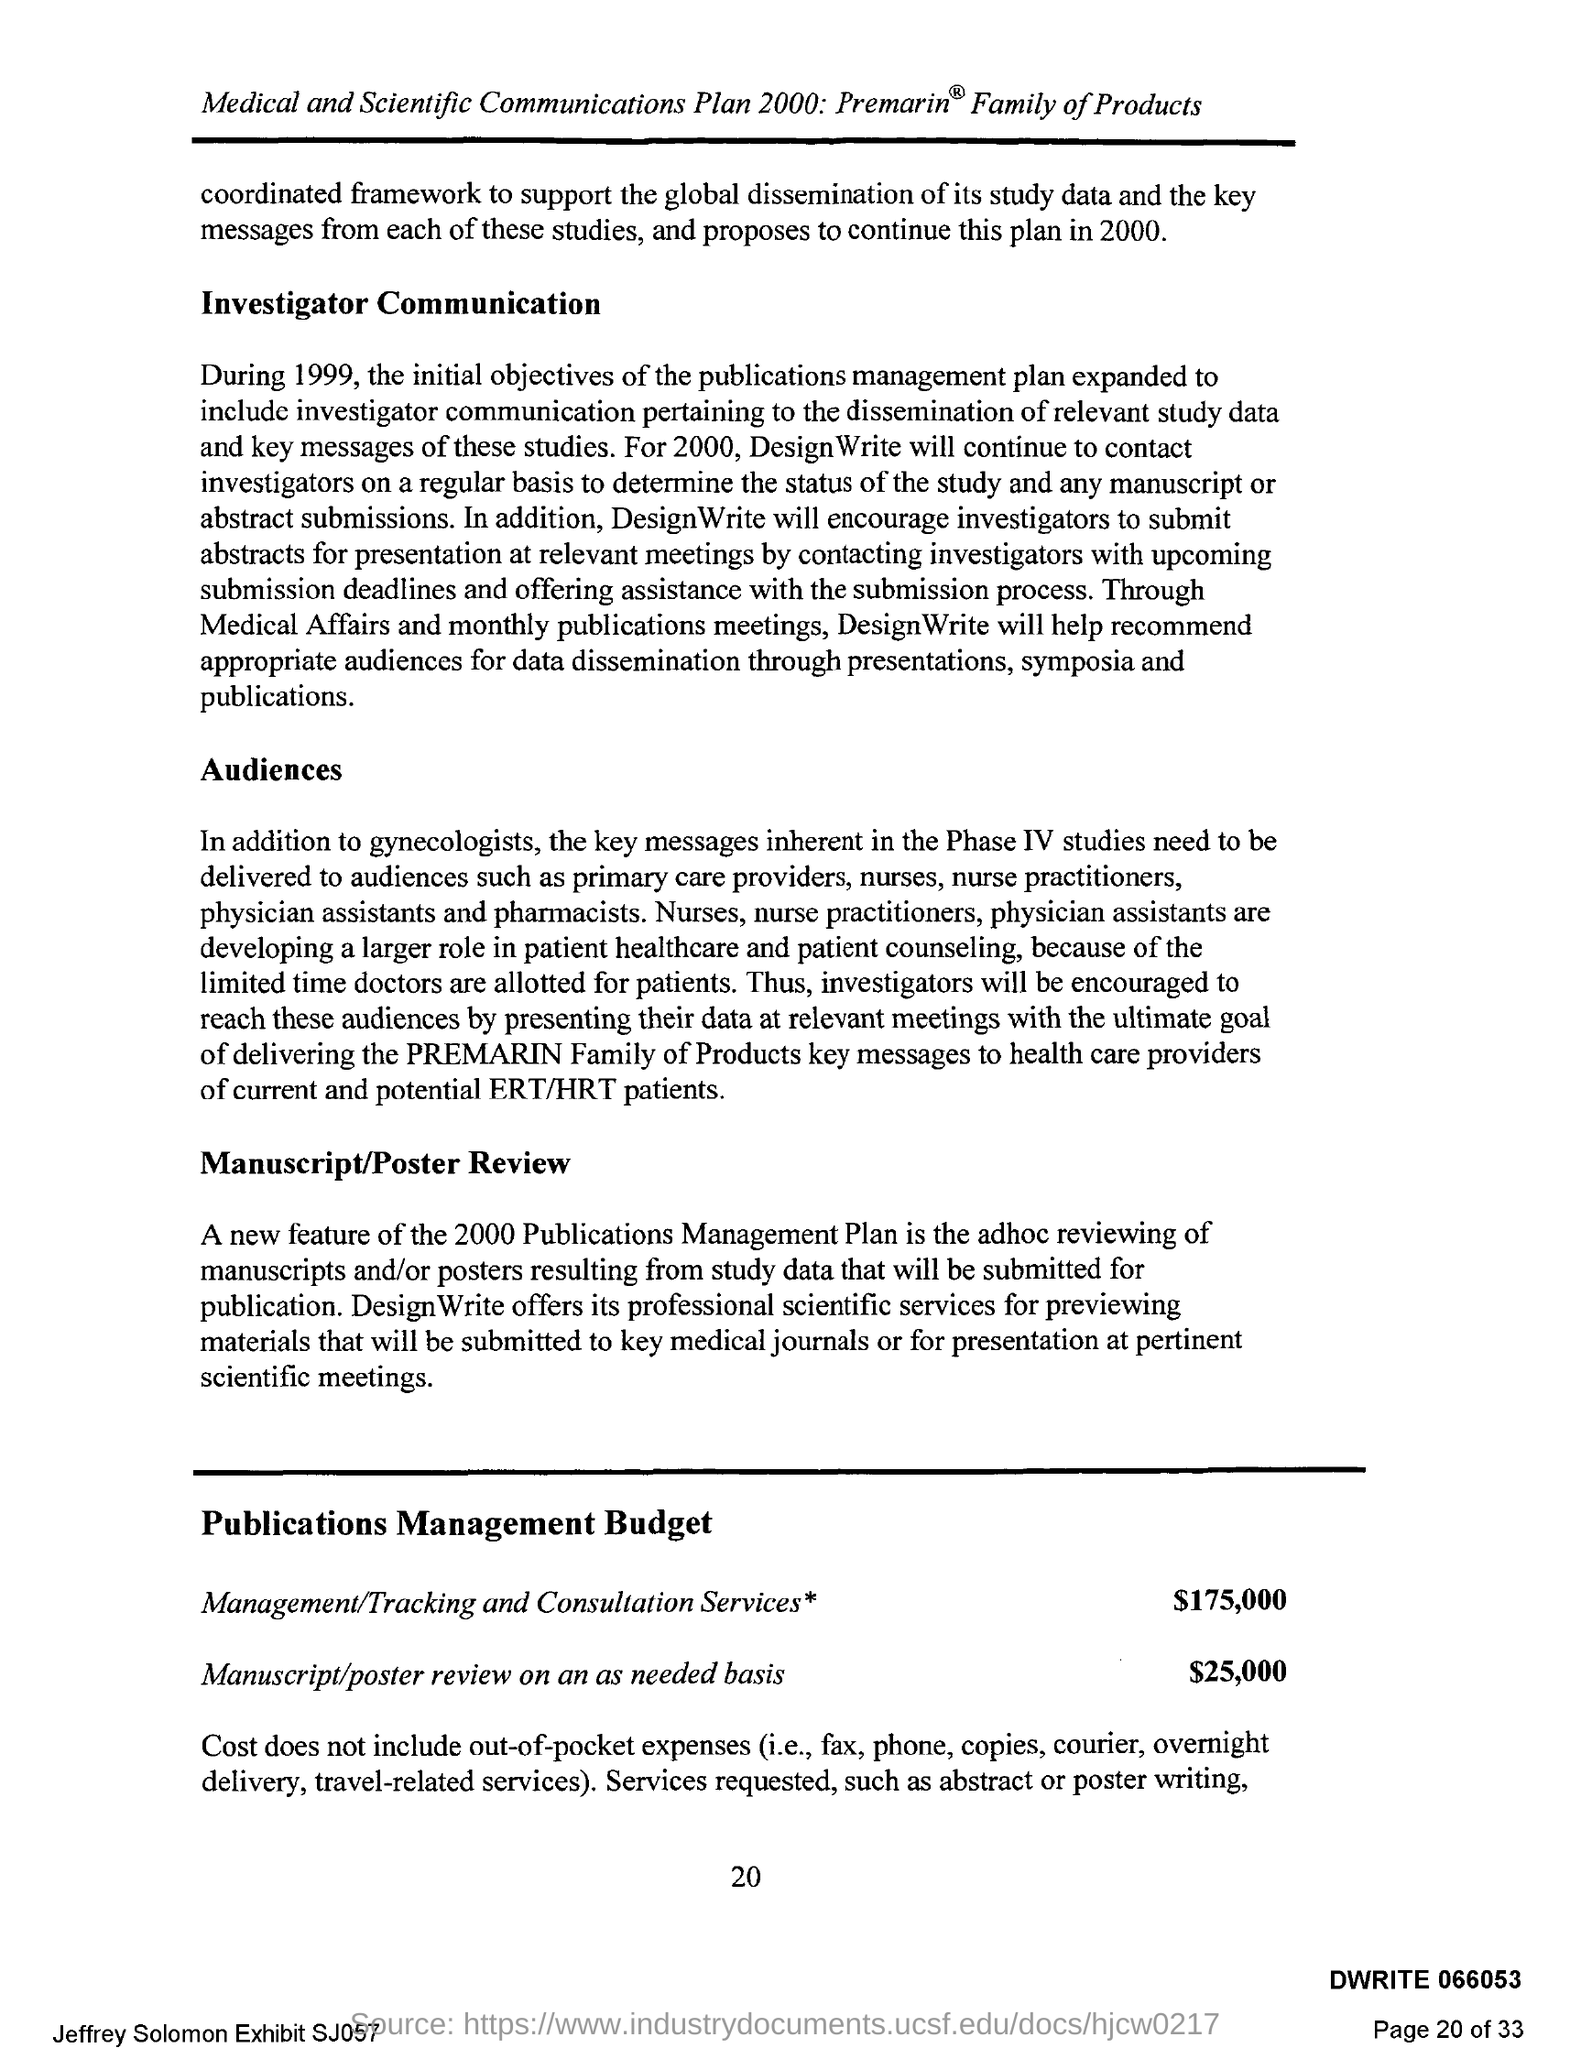Point out several critical features in this image. The budget for manuscript/poster review on an as-needed basis is $25,000. The budget for management and consultation services is $175,000. The text "What is the Page Number? 20.." is a question that seeks information about a specific page number. 